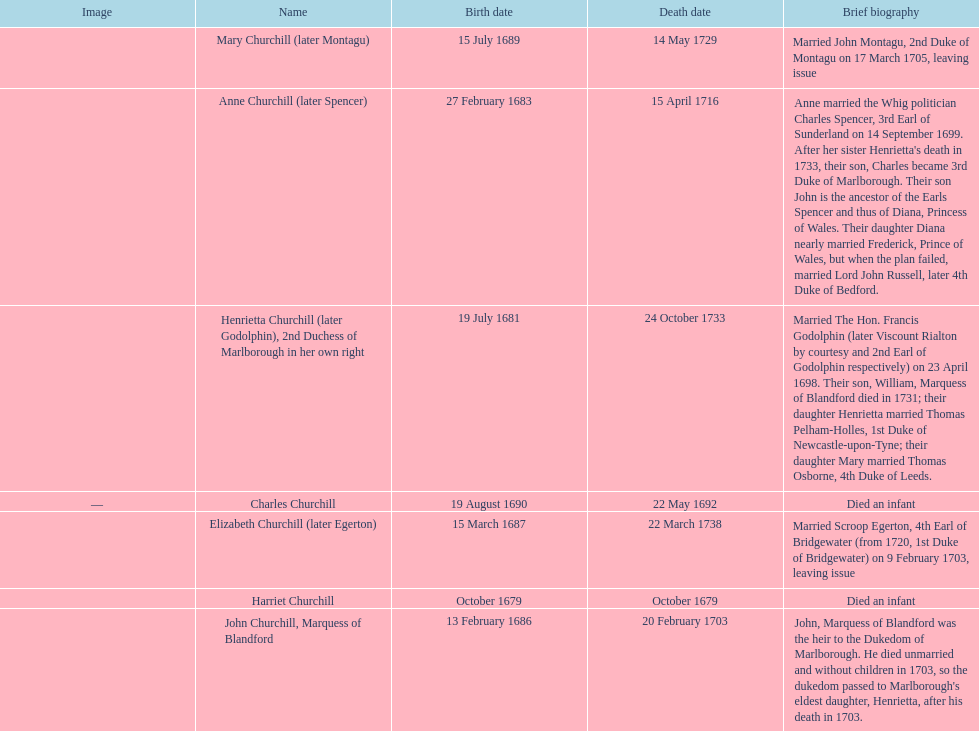What is the total number of children listed? 7. 